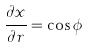Convert formula to latex. <formula><loc_0><loc_0><loc_500><loc_500>\frac { \partial x } { \partial r } = \cos \phi</formula> 